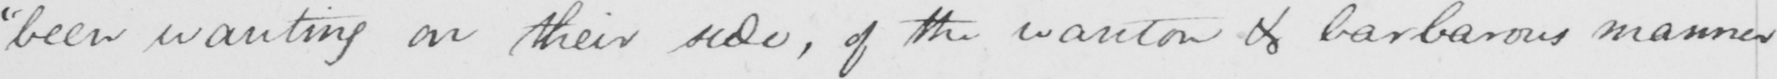Can you read and transcribe this handwriting? " been wanting on their side , of the wanton & barbarous manner 